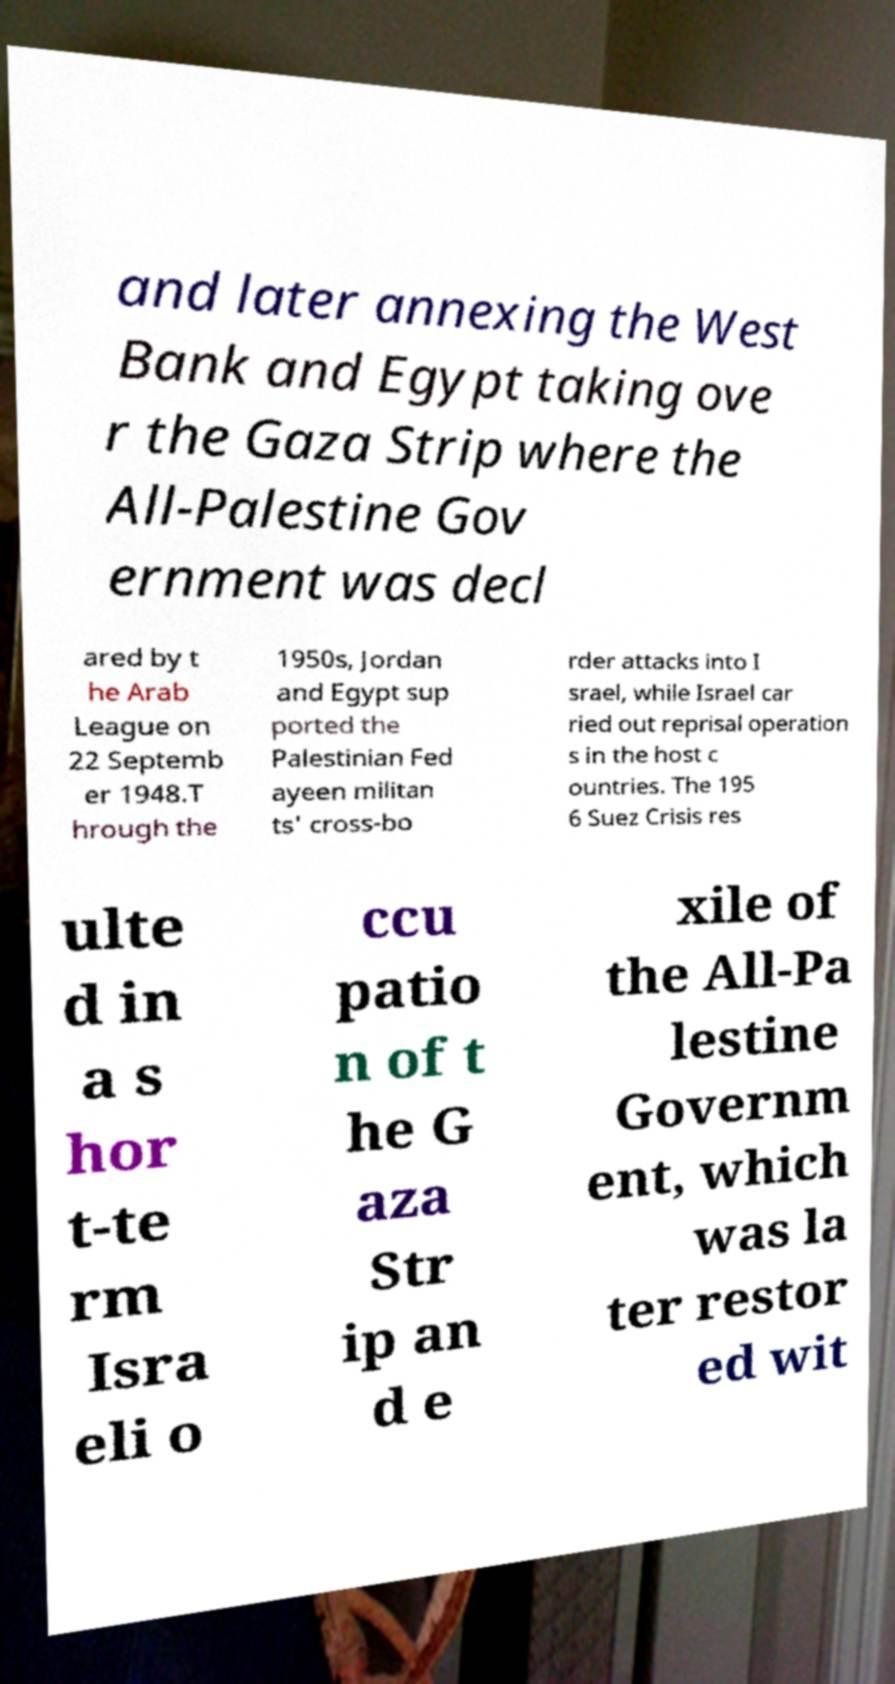Could you extract and type out the text from this image? and later annexing the West Bank and Egypt taking ove r the Gaza Strip where the All-Palestine Gov ernment was decl ared by t he Arab League on 22 Septemb er 1948.T hrough the 1950s, Jordan and Egypt sup ported the Palestinian Fed ayeen militan ts' cross-bo rder attacks into I srael, while Israel car ried out reprisal operation s in the host c ountries. The 195 6 Suez Crisis res ulte d in a s hor t-te rm Isra eli o ccu patio n of t he G aza Str ip an d e xile of the All-Pa lestine Governm ent, which was la ter restor ed wit 